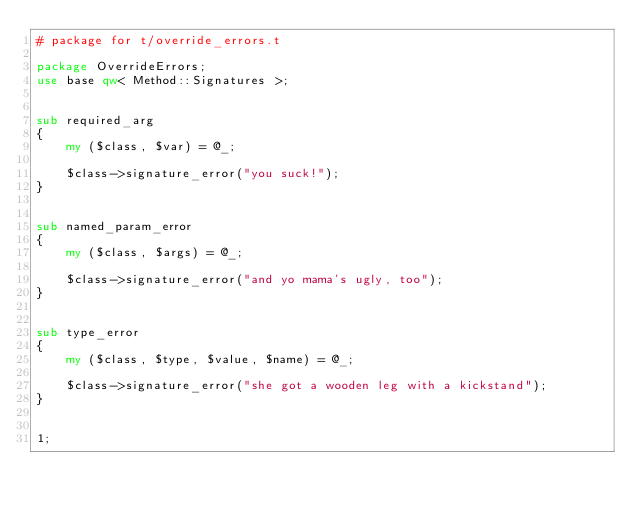Convert code to text. <code><loc_0><loc_0><loc_500><loc_500><_Perl_># package for t/override_errors.t

package OverrideErrors;
use base qw< Method::Signatures >;


sub required_arg
{
    my ($class, $var) = @_;

    $class->signature_error("you suck!");
}


sub named_param_error
{
    my ($class, $args) = @_;

    $class->signature_error("and yo mama's ugly, too");
}


sub type_error
{
    my ($class, $type, $value, $name) = @_;

    $class->signature_error("she got a wooden leg with a kickstand");
}


1;
</code> 